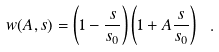<formula> <loc_0><loc_0><loc_500><loc_500>w ( A , s ) = \left ( 1 - { \frac { s } { s _ { 0 } } } \right ) \left ( 1 + A { \frac { s } { s _ { 0 } } } \right ) \ .</formula> 